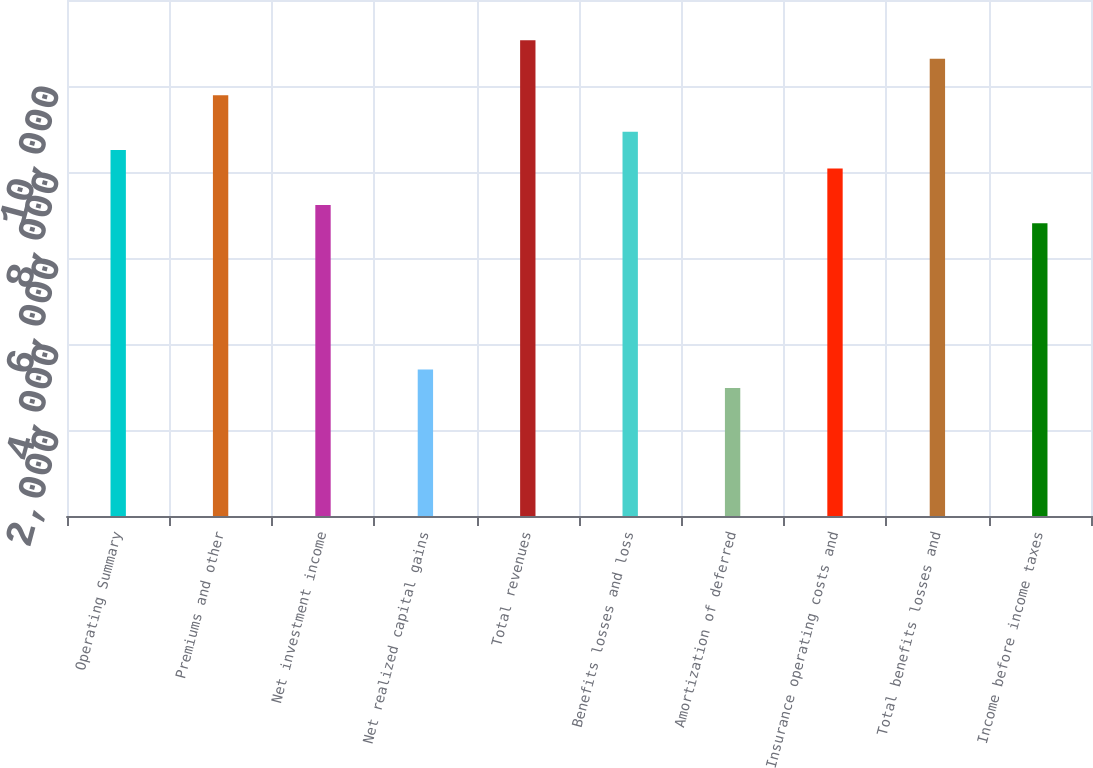Convert chart to OTSL. <chart><loc_0><loc_0><loc_500><loc_500><bar_chart><fcel>Operating Summary<fcel>Premiums and other<fcel>Net investment income<fcel>Net realized capital gains<fcel>Total revenues<fcel>Benefits losses and loss<fcel>Amortization of deferred<fcel>Insurance operating costs and<fcel>Total benefits losses and<fcel>Income before income taxes<nl><fcel>8509.4<fcel>9785.72<fcel>7233.08<fcel>3404.12<fcel>11062<fcel>8934.84<fcel>2978.68<fcel>8083.96<fcel>10636.6<fcel>6807.64<nl></chart> 